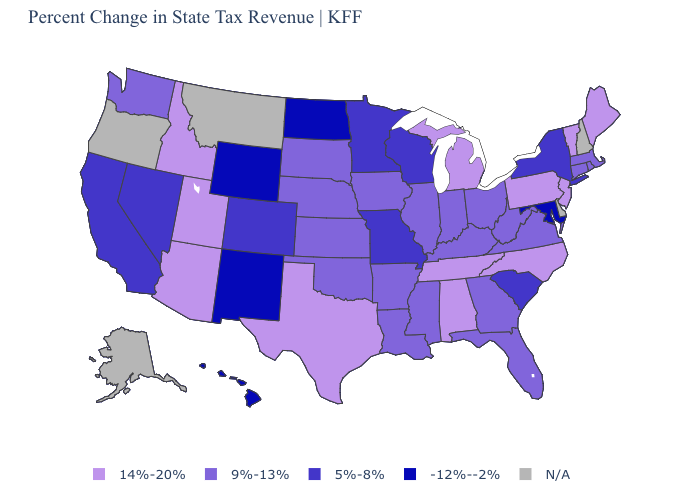Name the states that have a value in the range 14%-20%?
Short answer required. Alabama, Arizona, Idaho, Maine, Michigan, New Jersey, North Carolina, Pennsylvania, Tennessee, Texas, Utah, Vermont. Is the legend a continuous bar?
Keep it brief. No. Among the states that border Arizona , which have the highest value?
Give a very brief answer. Utah. What is the value of Michigan?
Be succinct. 14%-20%. Name the states that have a value in the range 5%-8%?
Quick response, please. California, Colorado, Minnesota, Missouri, Nevada, New York, South Carolina, Wisconsin. Does Nevada have the highest value in the USA?
Keep it brief. No. Name the states that have a value in the range N/A?
Write a very short answer. Alaska, Delaware, Montana, New Hampshire, Oregon. Name the states that have a value in the range N/A?
Answer briefly. Alaska, Delaware, Montana, New Hampshire, Oregon. What is the value of Alabama?
Concise answer only. 14%-20%. What is the highest value in the West ?
Concise answer only. 14%-20%. What is the value of Pennsylvania?
Short answer required. 14%-20%. Does the first symbol in the legend represent the smallest category?
Write a very short answer. No. Among the states that border Rhode Island , which have the highest value?
Answer briefly. Connecticut, Massachusetts. What is the value of North Carolina?
Give a very brief answer. 14%-20%. Does Michigan have the highest value in the MidWest?
Short answer required. Yes. 